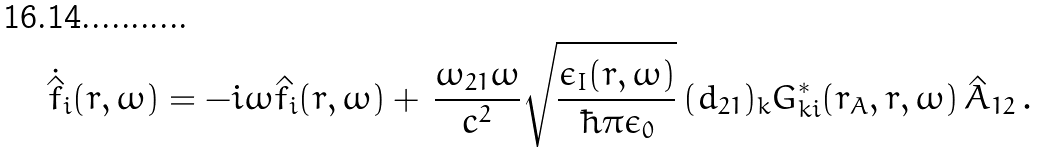<formula> <loc_0><loc_0><loc_500><loc_500>\, \dot { \hat { \, f } } _ { i } ( { r } , \omega ) = - i \omega \hat { f } _ { i } ( { r } , \omega ) + \, \frac { \omega _ { 2 1 } \omega } { c ^ { 2 } } \sqrt { \frac { \epsilon _ { I } ( { r } , \omega ) } { \hbar { \pi } \epsilon _ { 0 } } } \, ( d _ { 2 1 } ) _ { k } G _ { k i } ^ { \ast } ( { r } _ { A } , { r } , \omega ) \, \hat { A } _ { 1 2 } \, .</formula> 